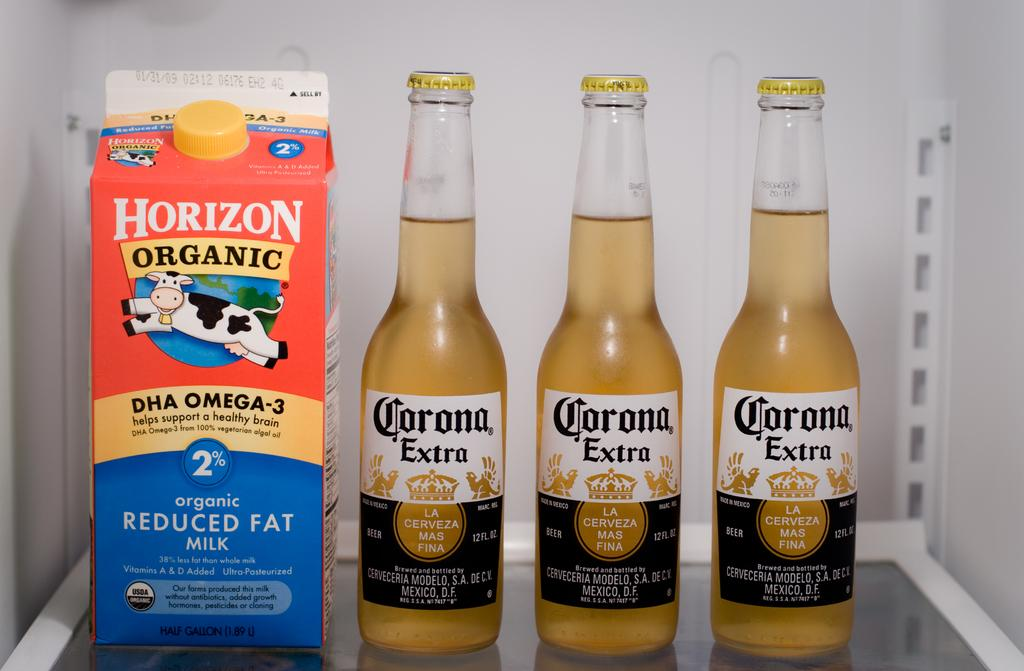Provide a one-sentence caption for the provided image. A carton of horizon organic milk is next to 3 bottle of corona on the shelf. 